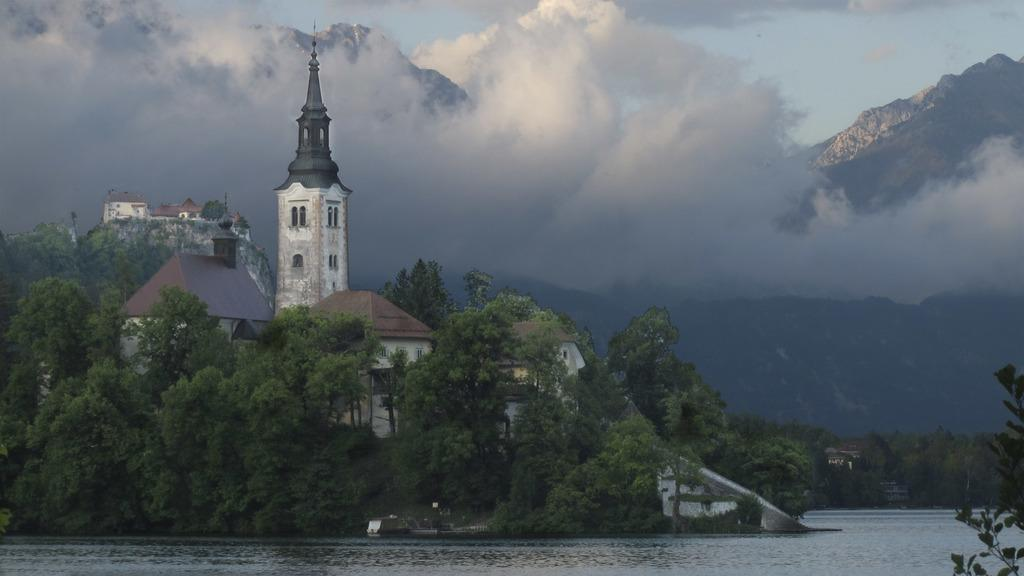What type of structures can be seen in the image? There are buildings in the image. What other natural elements are present in the image? There are trees and water visible in the image. What part of the natural environment is visible in the image? The sky is visible in the image. What color of crayon is being used to draw the buildings in the image? There is no crayon present in the image; it is a photograph or illustration of actual buildings. 